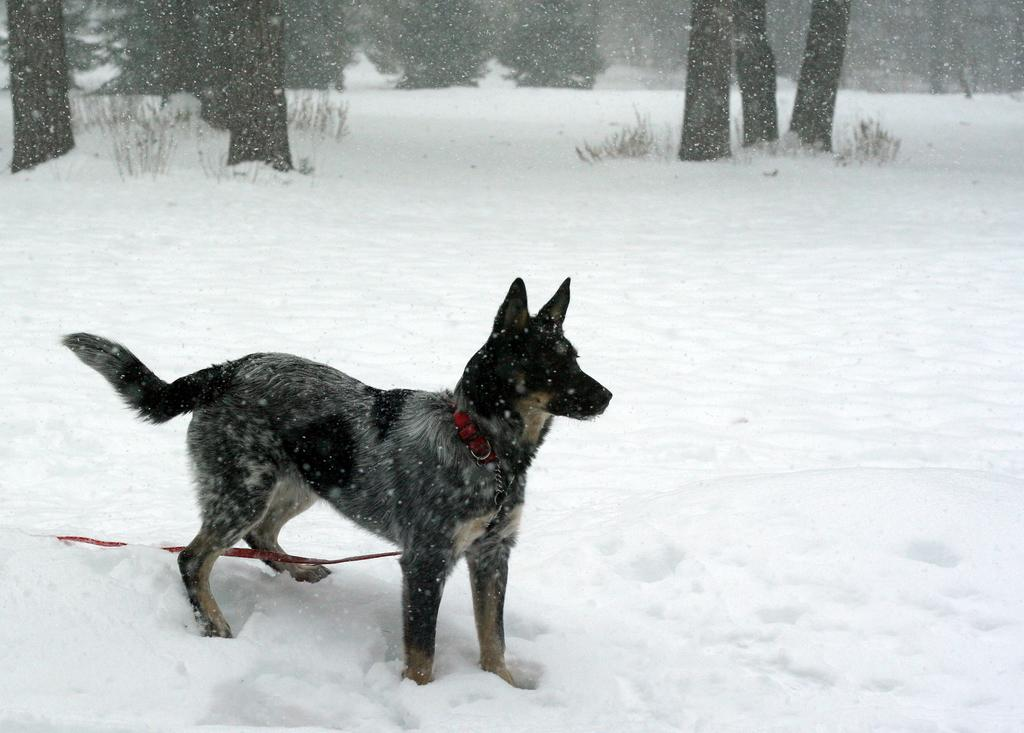What type of animal is in the image? There is a dog in the image. What colors can be seen on the dog? The dog is black and brown in color. What is the weather like in the image? There is snow visible in the image, indicating a cold or wintry setting. What type of vegetation is present in the image? There are trees in the image. What type of fuel is the dog using to keep warm in the image? The dog is not using any fuel to keep warm in the image; it is simply in a cold or wintry setting with snow. 